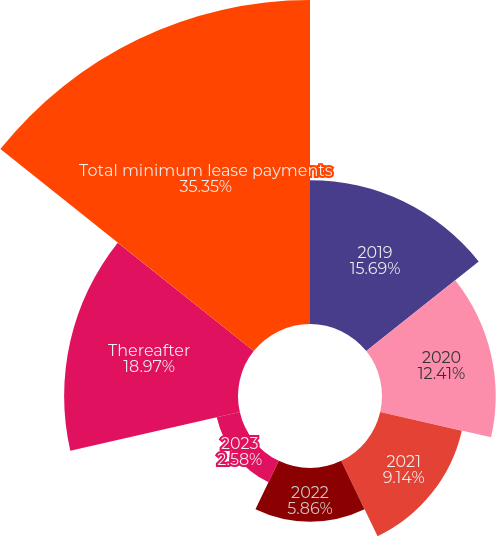Convert chart. <chart><loc_0><loc_0><loc_500><loc_500><pie_chart><fcel>2019<fcel>2020<fcel>2021<fcel>2022<fcel>2023<fcel>Thereafter<fcel>Total minimum lease payments<nl><fcel>15.69%<fcel>12.41%<fcel>9.14%<fcel>5.86%<fcel>2.58%<fcel>18.97%<fcel>35.35%<nl></chart> 